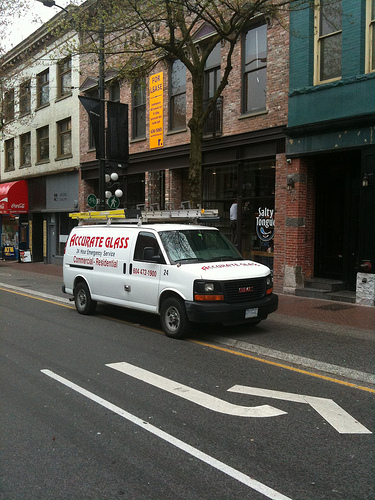<image>
Is the tire on the sidewalk? Yes. Looking at the image, I can see the tire is positioned on top of the sidewalk, with the sidewalk providing support. Is the car next to the wall? Yes. The car is positioned adjacent to the wall, located nearby in the same general area. 